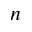<formula> <loc_0><loc_0><loc_500><loc_500>n</formula> 